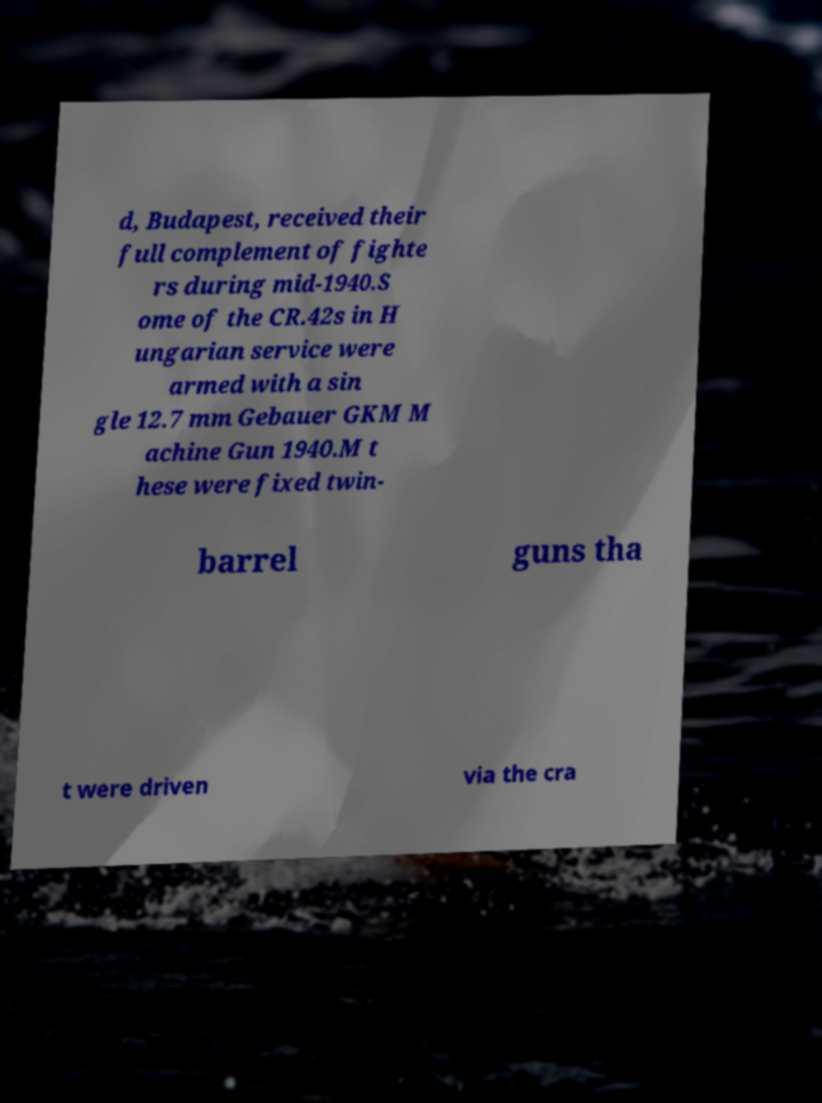For documentation purposes, I need the text within this image transcribed. Could you provide that? d, Budapest, received their full complement of fighte rs during mid-1940.S ome of the CR.42s in H ungarian service were armed with a sin gle 12.7 mm Gebauer GKM M achine Gun 1940.M t hese were fixed twin- barrel guns tha t were driven via the cra 